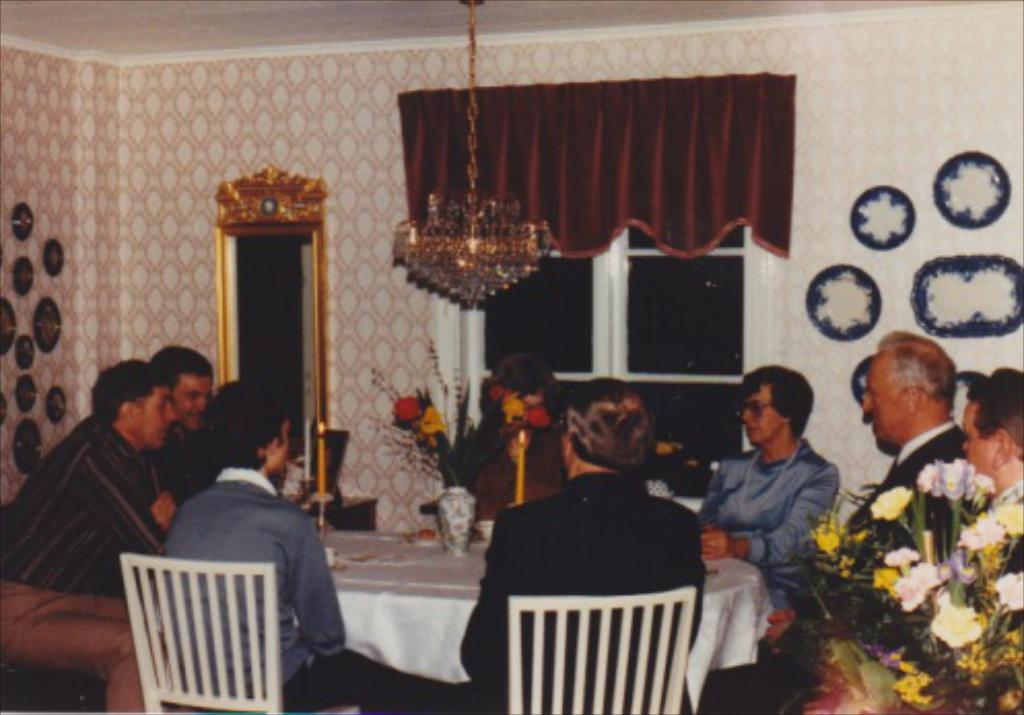What type of room is depicted in the image? There is a dining hall in the image. What are the people in the image doing? The people are sitting around a dining table. What can be seen on the dining table? There are different items on the dining table. Can you describe any decorative elements in the room? There is a flower vase in the room. What is the wealth distribution like in the town shown in the image? There is no town shown in the image, only a dining hall with people sitting around a dining table. Can you describe the veins in the leaves of the plant in the image? There is no plant with visible veins in the image; it features a dining hall with a flower vase. 